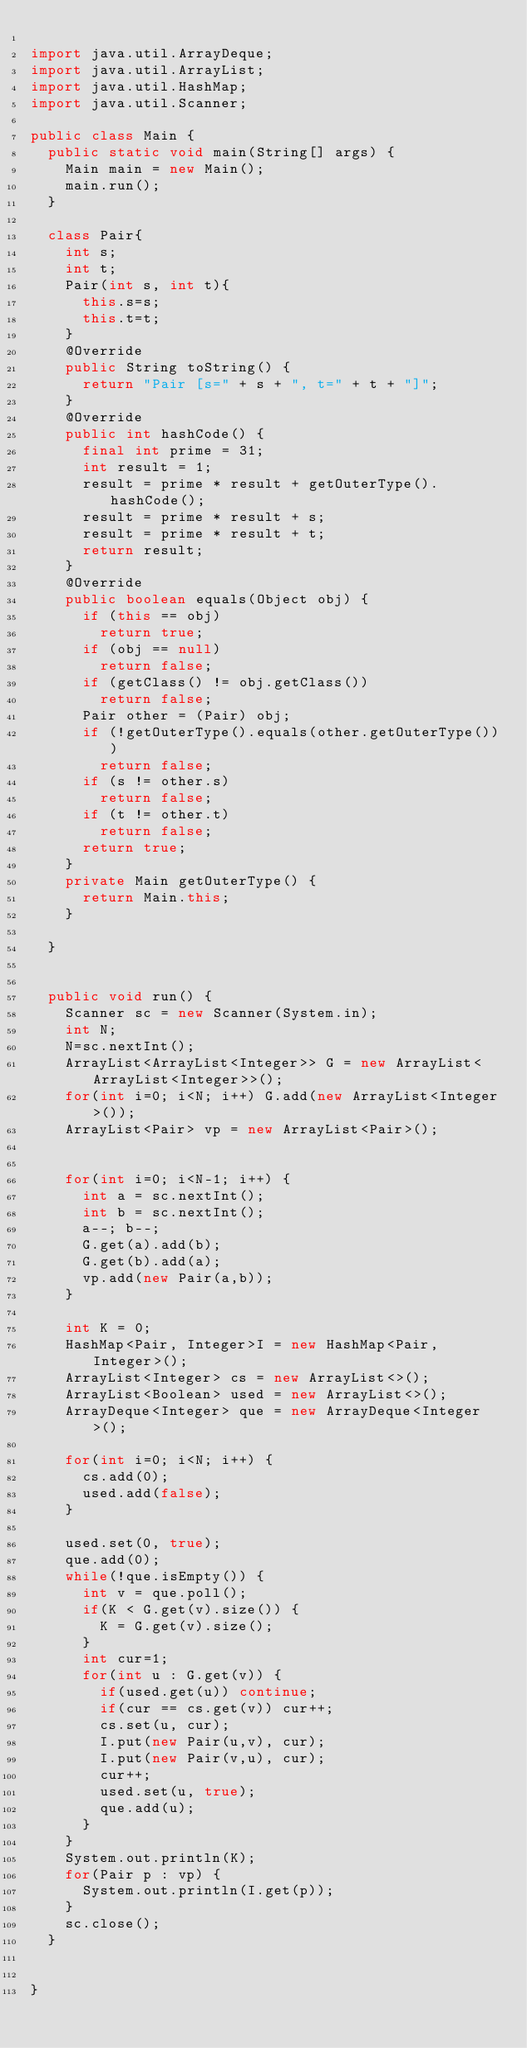Convert code to text. <code><loc_0><loc_0><loc_500><loc_500><_Java_>
import java.util.ArrayDeque;
import java.util.ArrayList;
import java.util.HashMap;
import java.util.Scanner;

public class Main {
	public static void main(String[] args) {
		Main main = new Main();
		main.run();
	}

	class Pair{
		int s;
		int t;
		Pair(int s, int t){
			this.s=s;
			this.t=t;
		}
		@Override
		public String toString() {
			return "Pair [s=" + s + ", t=" + t + "]";
		}
		@Override
		public int hashCode() {
			final int prime = 31;
			int result = 1;
			result = prime * result + getOuterType().hashCode();
			result = prime * result + s;
			result = prime * result + t;
			return result;
		}
		@Override
		public boolean equals(Object obj) {
			if (this == obj)
				return true;
			if (obj == null)
				return false;
			if (getClass() != obj.getClass())
				return false;
			Pair other = (Pair) obj;
			if (!getOuterType().equals(other.getOuterType()))
				return false;
			if (s != other.s)
				return false;
			if (t != other.t)
				return false;
			return true;
		}
		private Main getOuterType() {
			return Main.this;
		}

	}


	public void run() {
		Scanner sc = new Scanner(System.in);
		int N;
		N=sc.nextInt();
		ArrayList<ArrayList<Integer>> G = new ArrayList<ArrayList<Integer>>();
		for(int i=0; i<N; i++) G.add(new ArrayList<Integer>());
		ArrayList<Pair> vp = new ArrayList<Pair>();


		for(int i=0; i<N-1; i++) {
			int a = sc.nextInt();
			int b = sc.nextInt();
			a--; b--;
			G.get(a).add(b);
			G.get(b).add(a);
			vp.add(new Pair(a,b));
		}

		int K = 0;
		HashMap<Pair, Integer>I = new HashMap<Pair, Integer>();
		ArrayList<Integer> cs = new ArrayList<>();
		ArrayList<Boolean> used = new ArrayList<>();
		ArrayDeque<Integer> que = new ArrayDeque<Integer>();

		for(int i=0; i<N; i++) {
			cs.add(0);
			used.add(false);
		}

		used.set(0, true);
		que.add(0);
		while(!que.isEmpty()) {
			int v = que.poll();
			if(K < G.get(v).size()) {
				K = G.get(v).size();
			}
			int cur=1;
			for(int u : G.get(v)) {
				if(used.get(u))	continue;
				if(cur == cs.get(v)) cur++;
				cs.set(u, cur);
				I.put(new Pair(u,v), cur);
				I.put(new Pair(v,u), cur);
				cur++;
				used.set(u, true);
				que.add(u);
			}
		}
		System.out.println(K);
		for(Pair p : vp) {
			System.out.println(I.get(p));
		}
		sc.close();
	}


}
</code> 